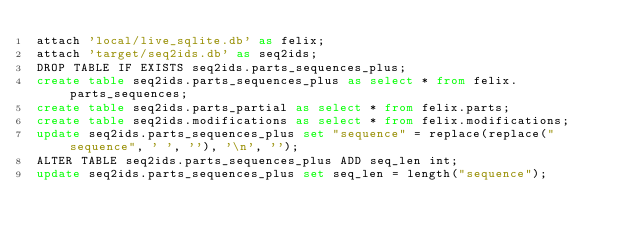Convert code to text. <code><loc_0><loc_0><loc_500><loc_500><_SQL_>attach 'local/live_sqlite.db' as felix;
attach 'target/seq2ids.db' as seq2ids;
DROP TABLE IF EXISTS seq2ids.parts_sequences_plus;
create table seq2ids.parts_sequences_plus as select * from felix.parts_sequences;
create table seq2ids.parts_partial as select * from felix.parts;
create table seq2ids.modifications as select * from felix.modifications;
update seq2ids.parts_sequences_plus set "sequence" = replace(replace("sequence", ' ', ''), '\n', '');
ALTER TABLE seq2ids.parts_sequences_plus ADD seq_len int;
update seq2ids.parts_sequences_plus set seq_len = length("sequence");
</code> 